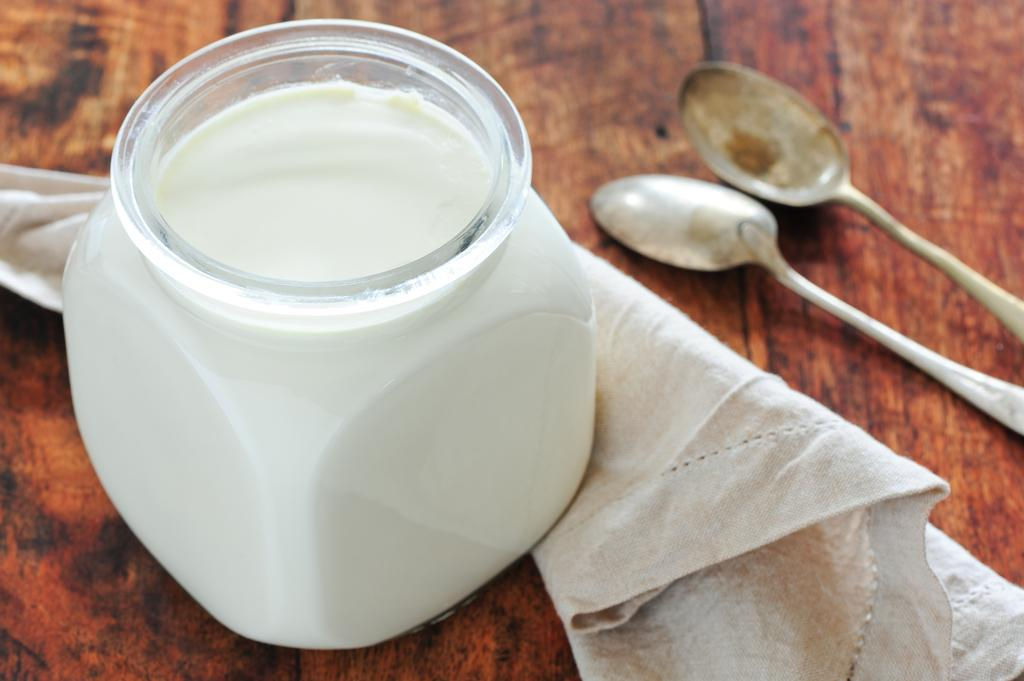What is located in the foreground of the image? There is a jar in the foreground of the image. What is inside the jar? The jar contains a white color substance. What other objects can be seen in the image? There is a cloth and a spoon in the image. What surface is the jar and other objects resting on? There appears to be a table at the bottom of the image. How many men are carrying the basket in the image? There is no basket or man present in the image. What type of sugar is being used in the image? There is no sugar present in the image. 